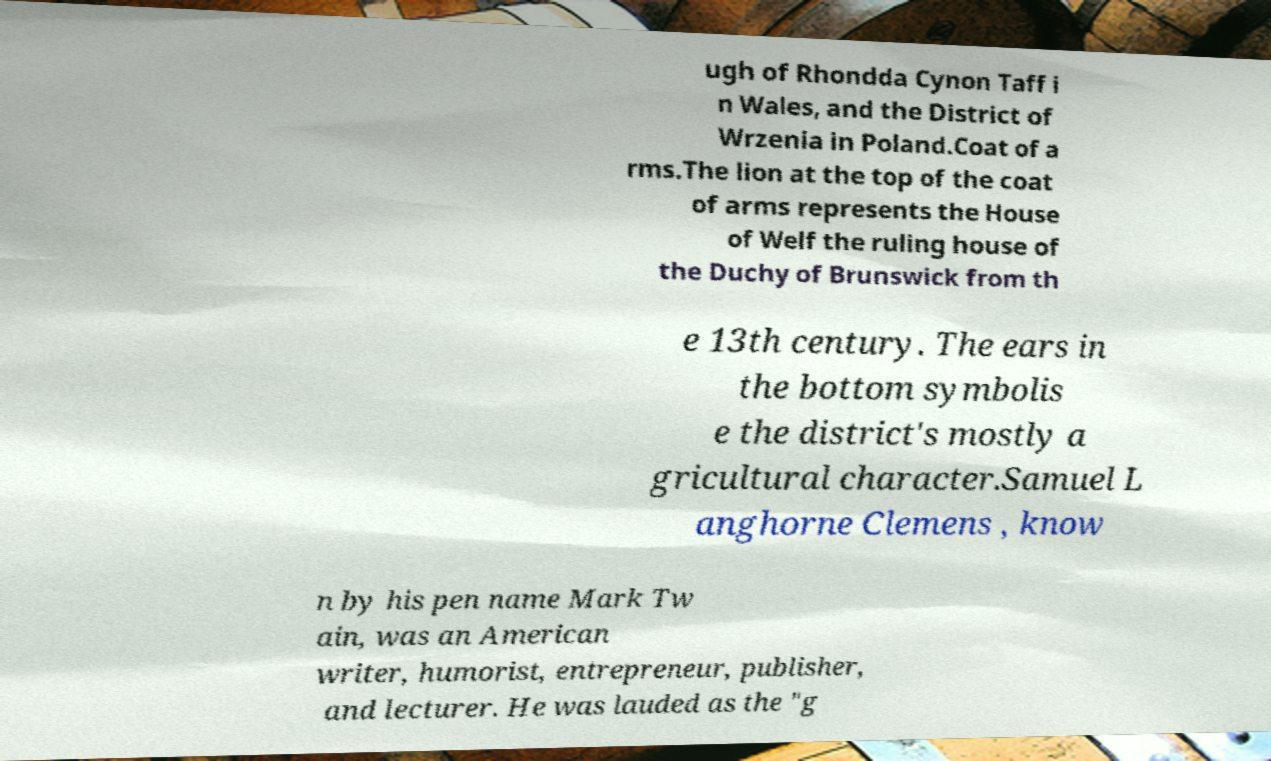Can you read and provide the text displayed in the image?This photo seems to have some interesting text. Can you extract and type it out for me? ugh of Rhondda Cynon Taff i n Wales, and the District of Wrzenia in Poland.Coat of a rms.The lion at the top of the coat of arms represents the House of Welf the ruling house of the Duchy of Brunswick from th e 13th century. The ears in the bottom symbolis e the district's mostly a gricultural character.Samuel L anghorne Clemens , know n by his pen name Mark Tw ain, was an American writer, humorist, entrepreneur, publisher, and lecturer. He was lauded as the "g 